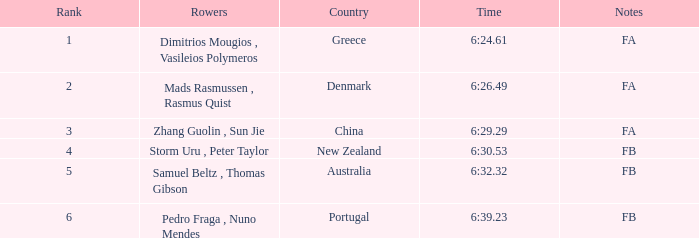What is the rank of the time of 6:30.53? 1.0. 